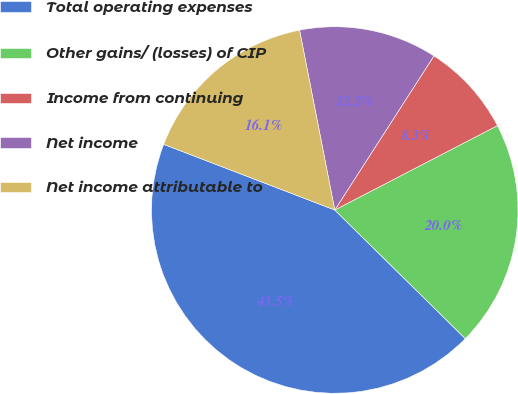Convert chart. <chart><loc_0><loc_0><loc_500><loc_500><pie_chart><fcel>Total operating expenses<fcel>Other gains/ (losses) of CIP<fcel>Income from continuing<fcel>Net income<fcel>Net income attributable to<nl><fcel>43.45%<fcel>20.0%<fcel>8.28%<fcel>12.18%<fcel>16.09%<nl></chart> 